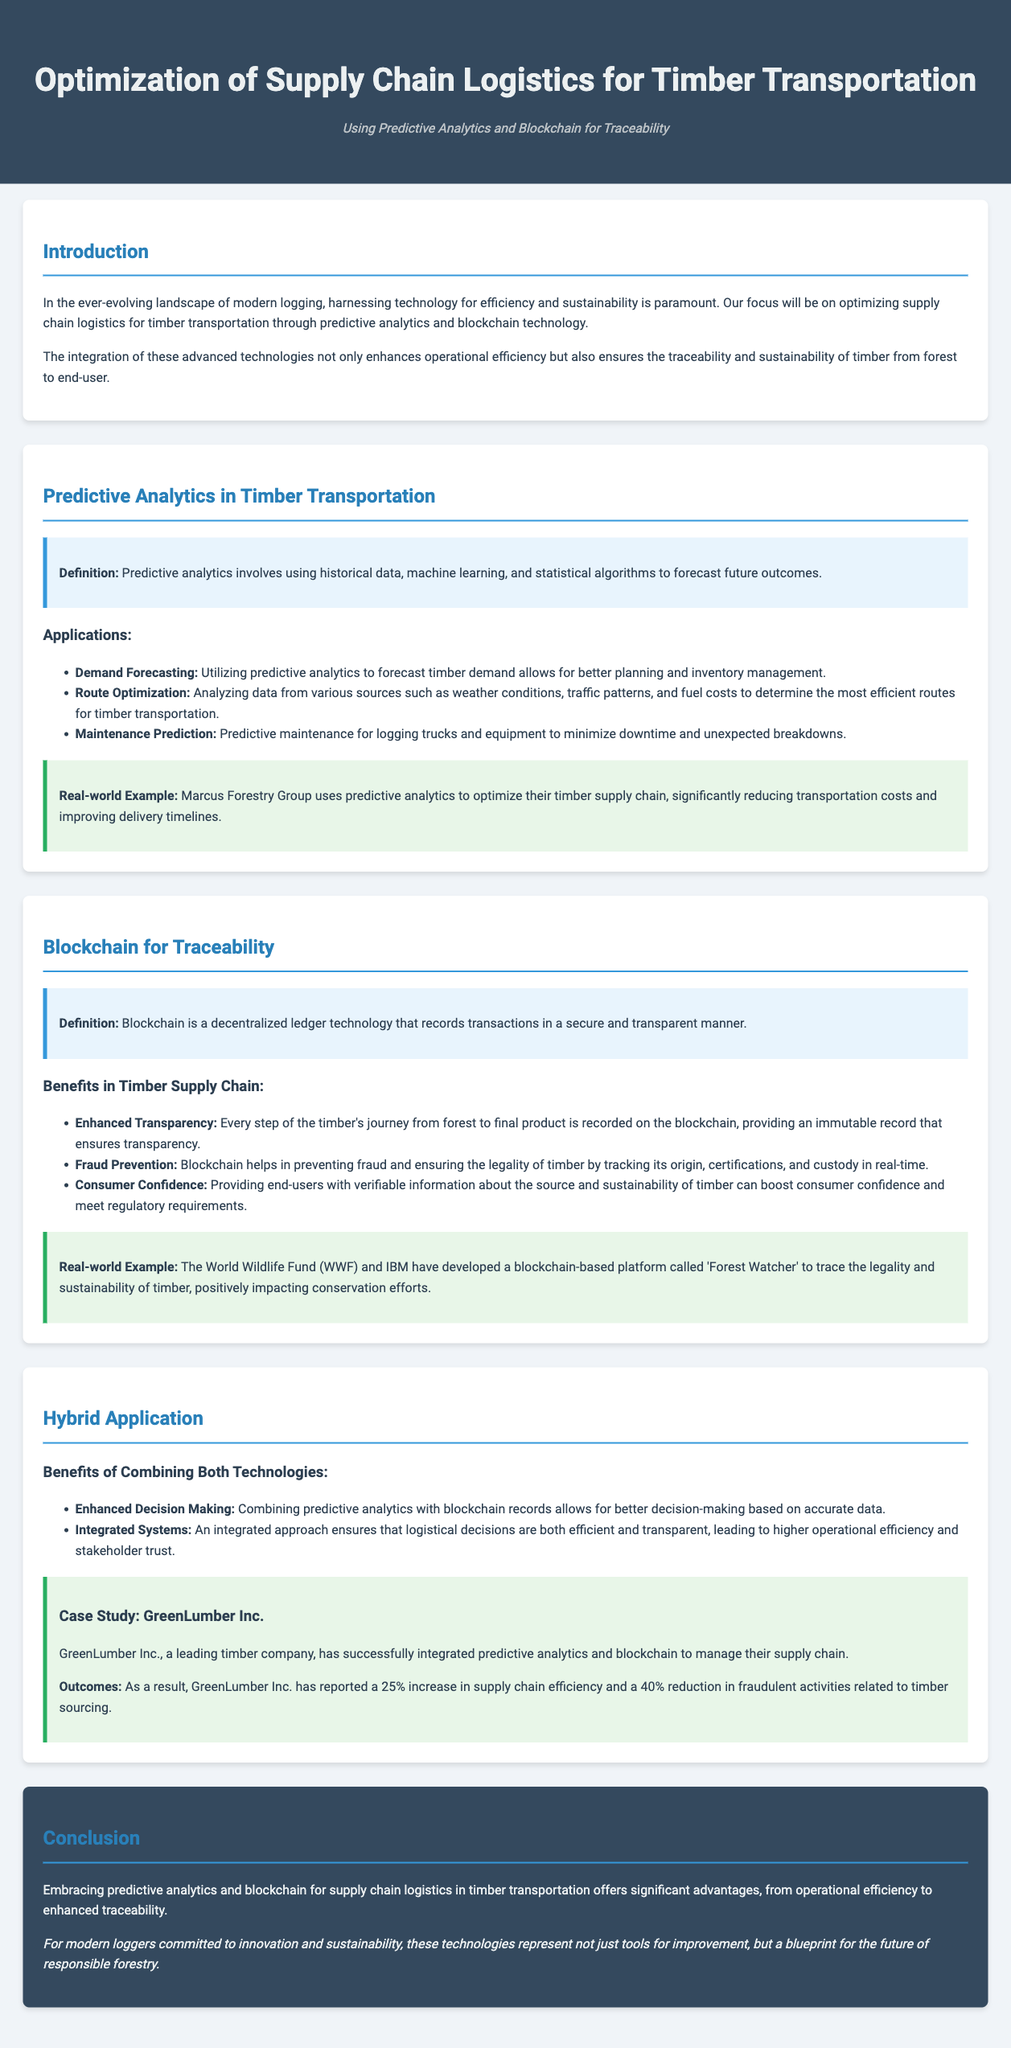What is the primary technology used for optimizing timber supply chain logistics? The document states that the primary technology being focused on is predictive analytics and blockchain for traceability in timber transportation.
Answer: predictive analytics and blockchain What organization developed the 'Forest Watcher' platform? The document mentions that the World Wildlife Fund (WWF) and IBM developed the blockchain-based platform called 'Forest Watcher.'
Answer: World Wildlife Fund (WWF) and IBM What percentage increase in supply chain efficiency did GreenLumber Inc. report? According to the case study, GreenLumber Inc. reported a 25% increase in supply chain efficiency.
Answer: 25% What are two applications of predictive analytics in timber transportation? The document lists demand forecasting and route optimization as two applications of predictive analytics in timber transportation.
Answer: demand forecasting, route optimization What is one benefit of using blockchain in timber supply chains? The document states that one benefit of blockchain is enhanced transparency for every step of the timber's journey from forest to final product.
Answer: enhanced transparency How does combining predictive analytics with blockchain impact decision-making? The document explains that combining both technologies allows for better decision-making based on accurate data.
Answer: better decision-making What type of maintenance can predictive analytics help with in timber transportation? The document indicates that predictive maintenance for logging trucks and equipment can be enhanced through predictive analytics.
Answer: predictive maintenance What is the subtitle of the document? The subtitle provided under the title in the document is focused on the technologies being discussed, which is about efficiency and traceability.
Answer: Using Predictive Analytics and Blockchain for Traceability 